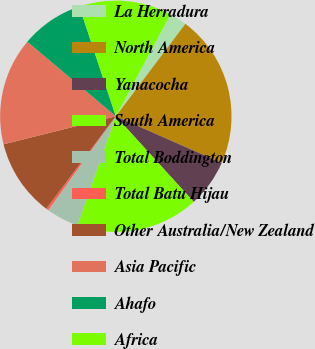Convert chart. <chart><loc_0><loc_0><loc_500><loc_500><pie_chart><fcel>La Herradura<fcel>North America<fcel>Yanacocha<fcel>South America<fcel>Total Boddington<fcel>Total Batu Hijau<fcel>Other Australia/New Zealand<fcel>Asia Pacific<fcel>Ahafo<fcel>Africa<nl><fcel>2.44%<fcel>21.34%<fcel>6.64%<fcel>17.14%<fcel>4.54%<fcel>0.34%<fcel>10.84%<fcel>15.04%<fcel>8.74%<fcel>12.94%<nl></chart> 